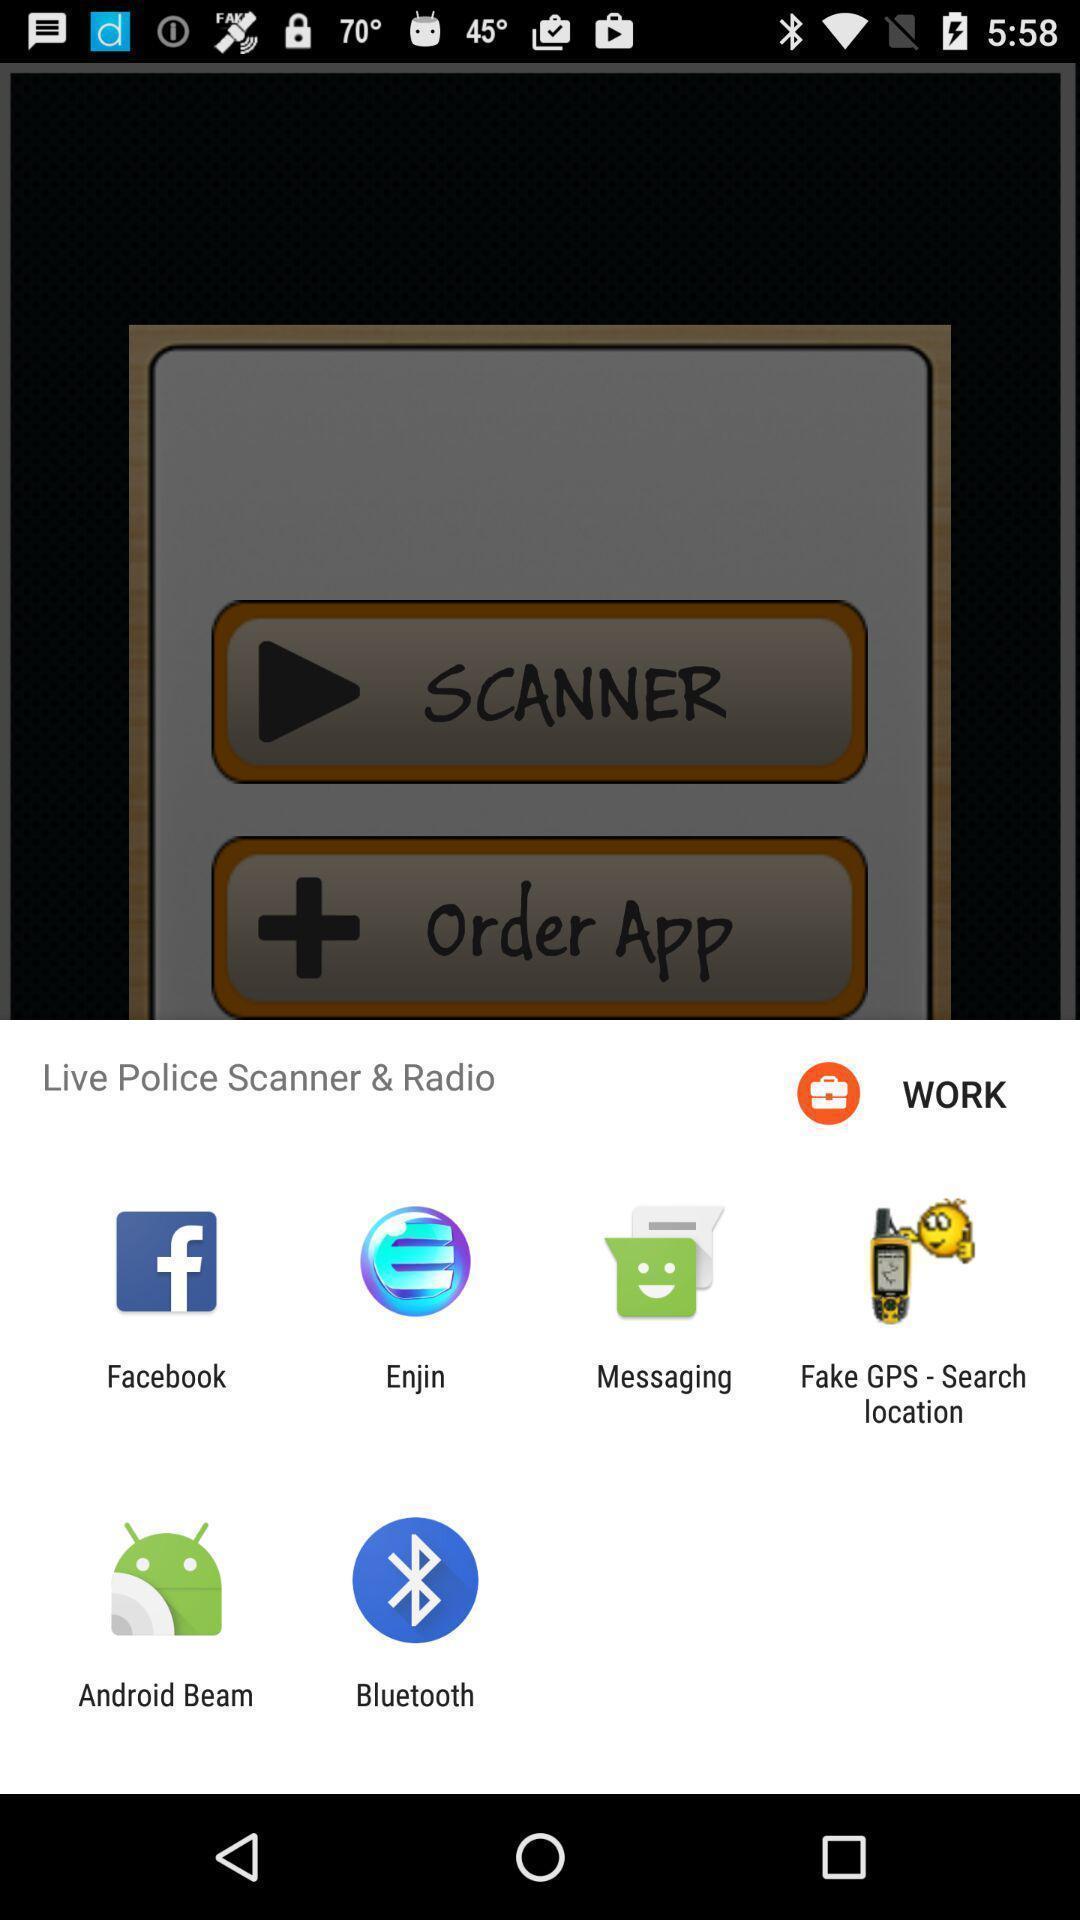Summarize the information in this screenshot. Pop-up displaying various apps for live police scanner. 